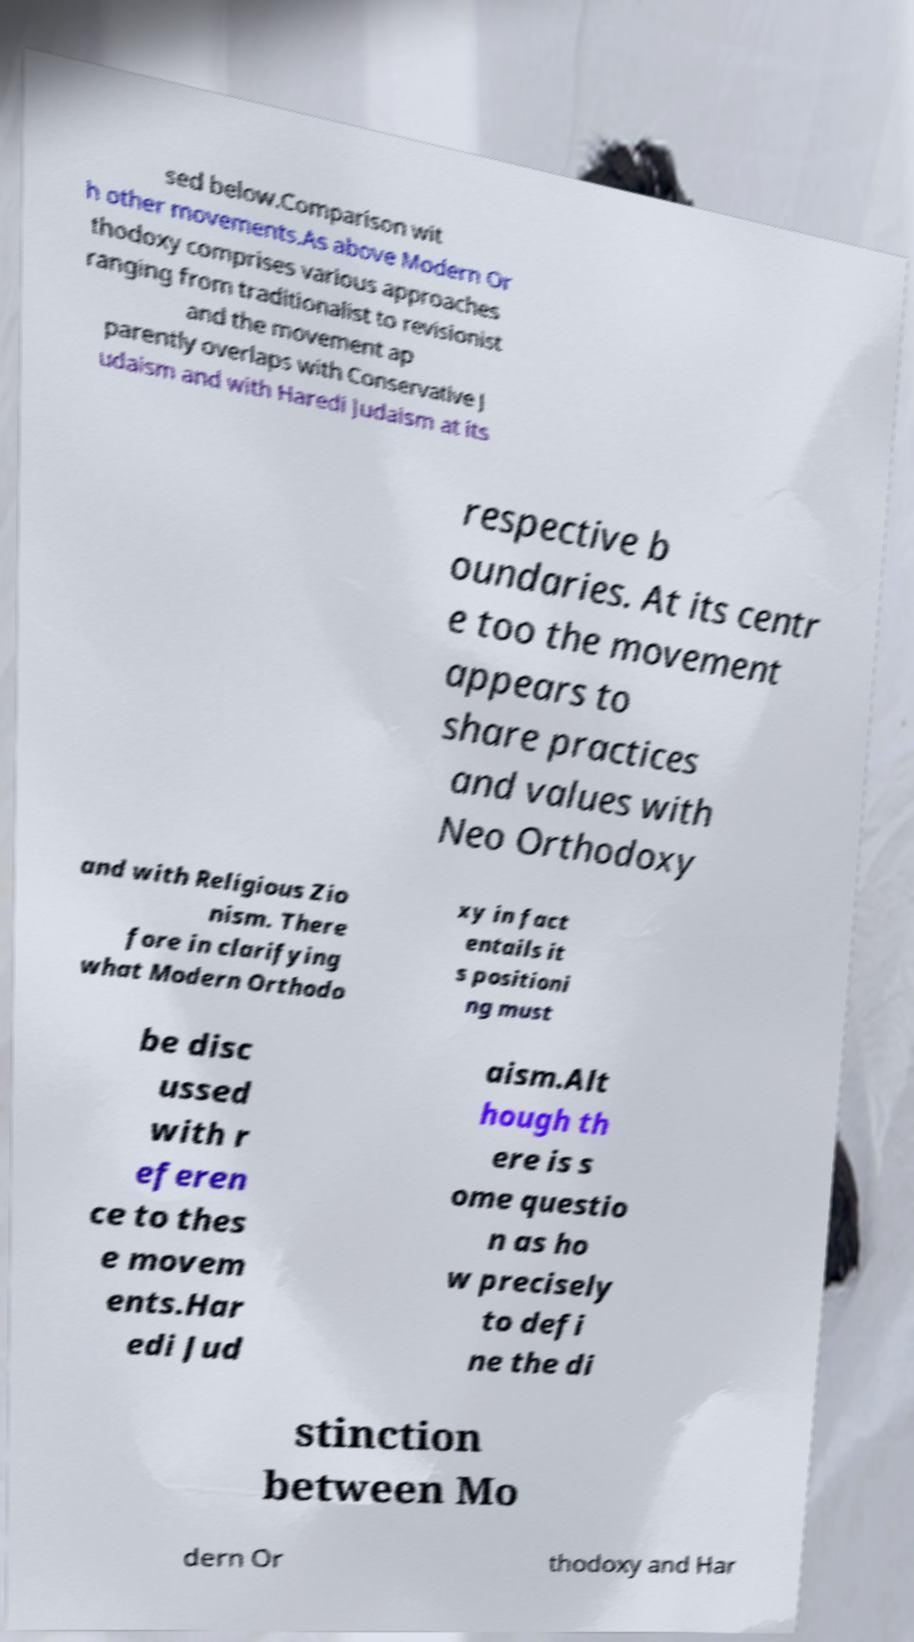For documentation purposes, I need the text within this image transcribed. Could you provide that? sed below.Comparison wit h other movements.As above Modern Or thodoxy comprises various approaches ranging from traditionalist to revisionist and the movement ap parently overlaps with Conservative J udaism and with Haredi Judaism at its respective b oundaries. At its centr e too the movement appears to share practices and values with Neo Orthodoxy and with Religious Zio nism. There fore in clarifying what Modern Orthodo xy in fact entails it s positioni ng must be disc ussed with r eferen ce to thes e movem ents.Har edi Jud aism.Alt hough th ere is s ome questio n as ho w precisely to defi ne the di stinction between Mo dern Or thodoxy and Har 